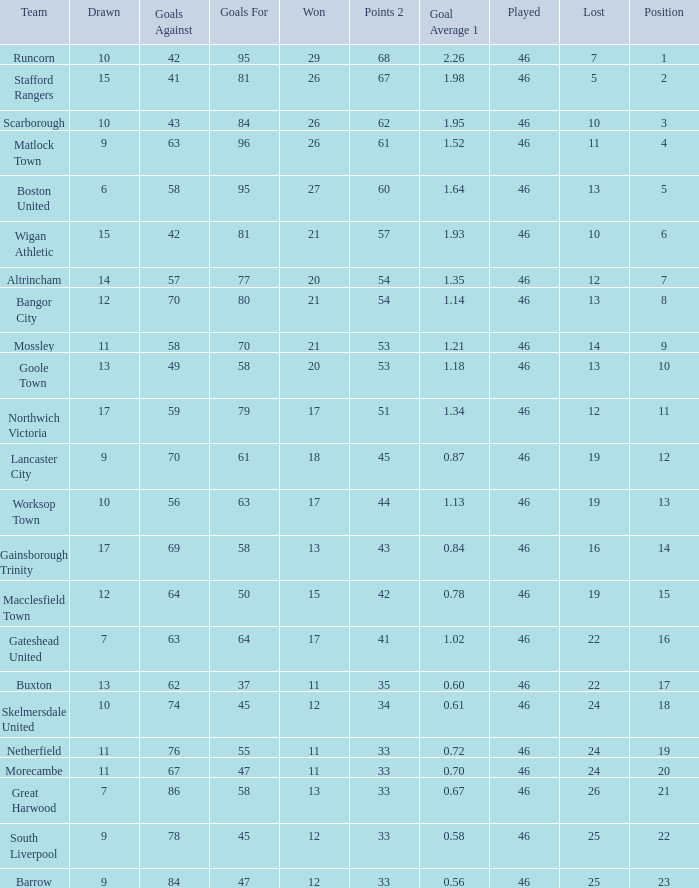How many times did the Lancaster City team play? 1.0. 